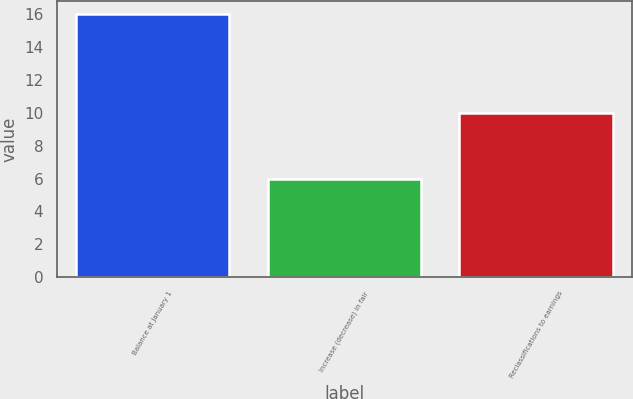<chart> <loc_0><loc_0><loc_500><loc_500><bar_chart><fcel>Balance at January 1<fcel>Increase (decrease) in fair<fcel>Reclassifications to earnings<nl><fcel>16<fcel>6<fcel>10<nl></chart> 